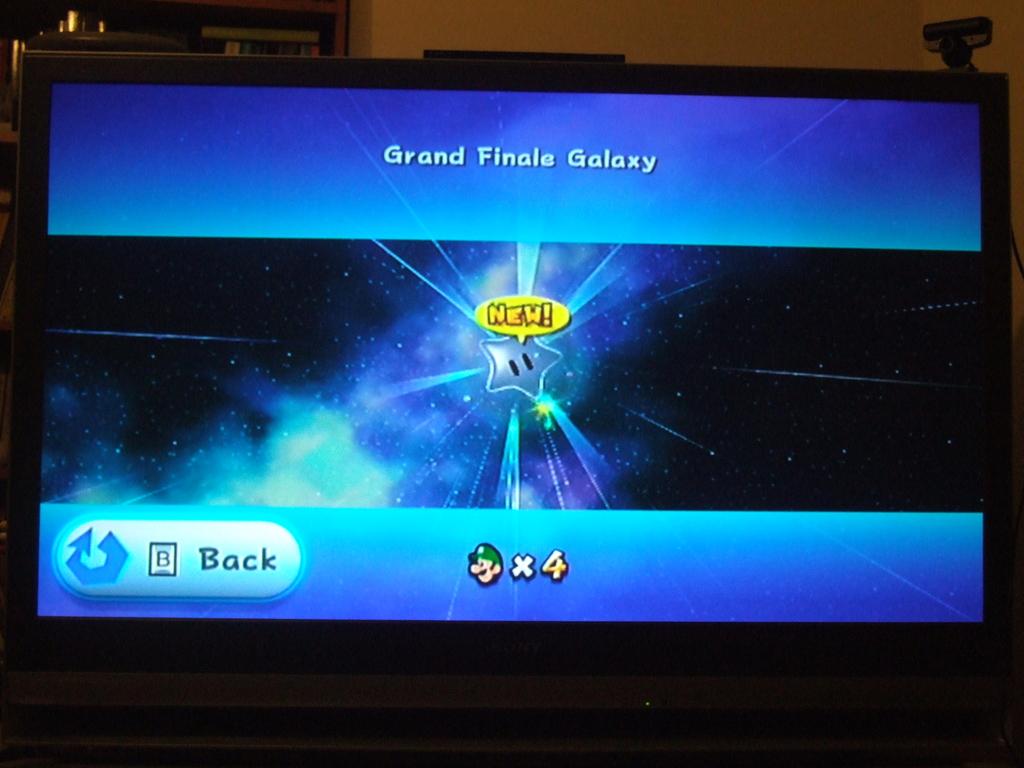What is the star saying in the speech bubble?
Make the answer very short. New. 